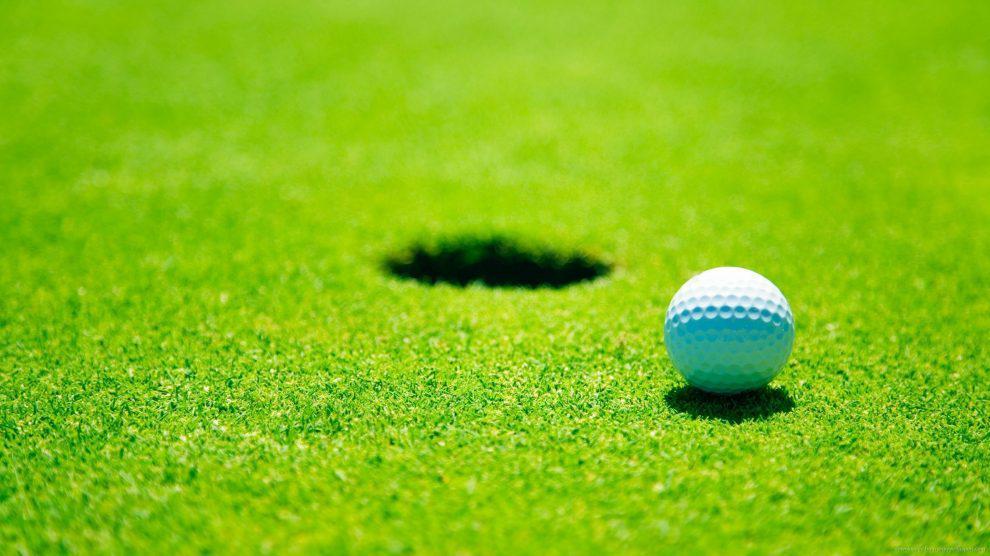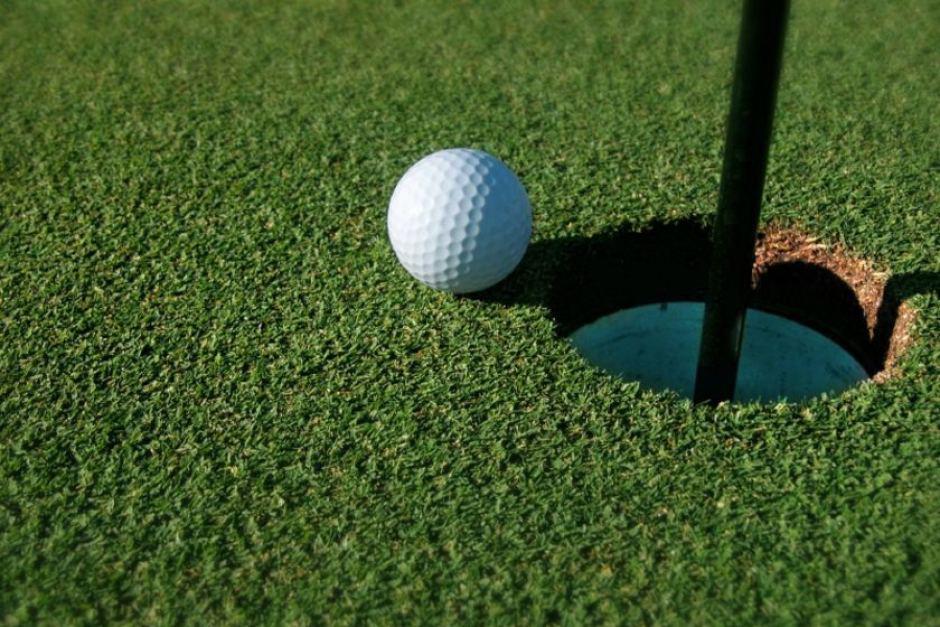The first image is the image on the left, the second image is the image on the right. Assess this claim about the two images: "One image shows a golf ball at the edge of a hole that has a pole in it, but not inside the hole.". Correct or not? Answer yes or no. Yes. The first image is the image on the left, the second image is the image on the right. Considering the images on both sides, is "In one of the images there is a golf ball on the very edge of a hole that has the flag pole in it." valid? Answer yes or no. Yes. 